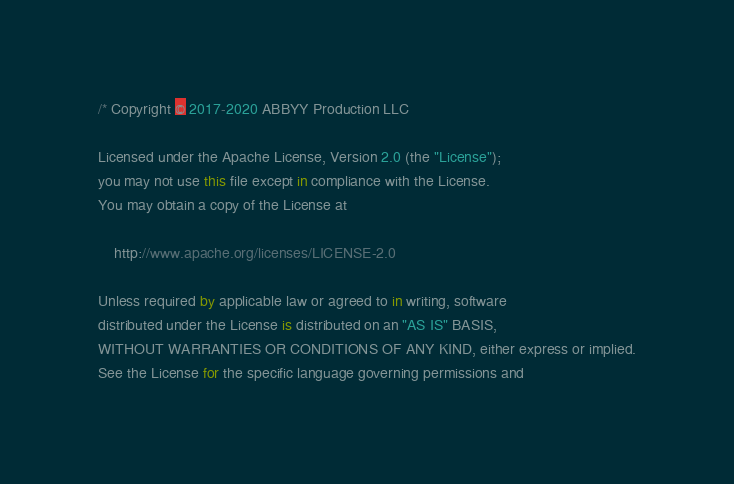Convert code to text. <code><loc_0><loc_0><loc_500><loc_500><_Kotlin_>/* Copyright © 2017-2020 ABBYY Production LLC

Licensed under the Apache License, Version 2.0 (the "License");
you may not use this file except in compliance with the License.
You may obtain a copy of the License at

	http://www.apache.org/licenses/LICENSE-2.0

Unless required by applicable law or agreed to in writing, software
distributed under the License is distributed on an "AS IS" BASIS,
WITHOUT WARRANTIES OR CONDITIONS OF ANY KIND, either express or implied.
See the License for the specific language governing permissions and</code> 